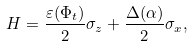Convert formula to latex. <formula><loc_0><loc_0><loc_500><loc_500>H = \frac { \varepsilon ( \Phi _ { t } ) } { 2 } \sigma _ { z } + \frac { \Delta ( \alpha ) } { 2 } \sigma _ { x } ,</formula> 